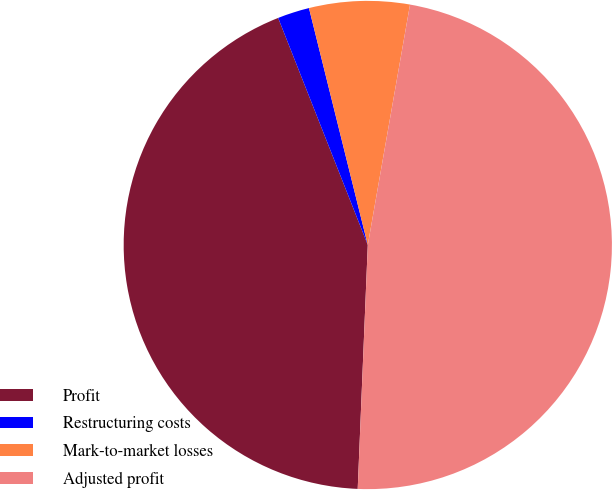Convert chart. <chart><loc_0><loc_0><loc_500><loc_500><pie_chart><fcel>Profit<fcel>Restructuring costs<fcel>Mark-to-market losses<fcel>Adjusted profit<nl><fcel>43.36%<fcel>2.11%<fcel>6.64%<fcel>47.89%<nl></chart> 